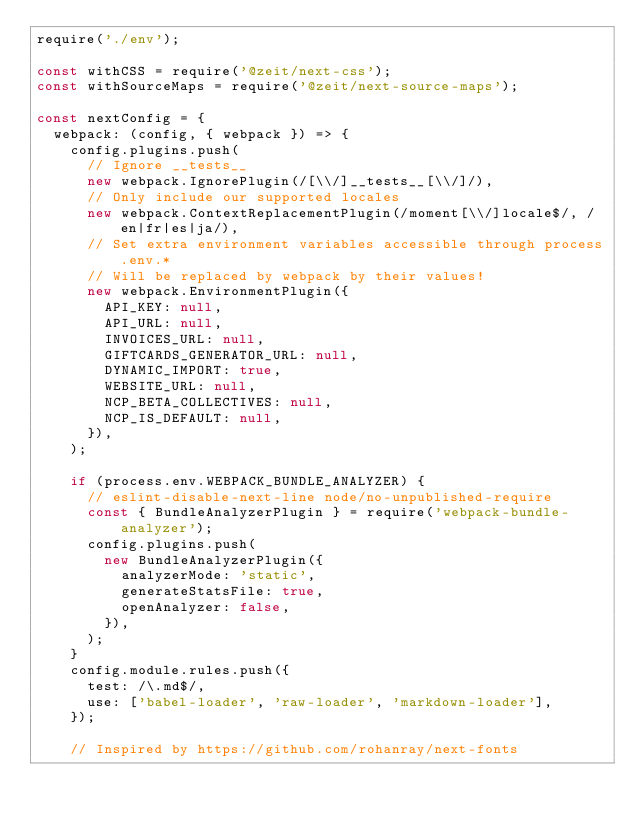<code> <loc_0><loc_0><loc_500><loc_500><_JavaScript_>require('./env');

const withCSS = require('@zeit/next-css');
const withSourceMaps = require('@zeit/next-source-maps');

const nextConfig = {
  webpack: (config, { webpack }) => {
    config.plugins.push(
      // Ignore __tests__
      new webpack.IgnorePlugin(/[\\/]__tests__[\\/]/),
      // Only include our supported locales
      new webpack.ContextReplacementPlugin(/moment[\\/]locale$/, /en|fr|es|ja/),
      // Set extra environment variables accessible through process.env.*
      // Will be replaced by webpack by their values!
      new webpack.EnvironmentPlugin({
        API_KEY: null,
        API_URL: null,
        INVOICES_URL: null,
        GIFTCARDS_GENERATOR_URL: null,
        DYNAMIC_IMPORT: true,
        WEBSITE_URL: null,
        NCP_BETA_COLLECTIVES: null,
        NCP_IS_DEFAULT: null,
      }),
    );

    if (process.env.WEBPACK_BUNDLE_ANALYZER) {
      // eslint-disable-next-line node/no-unpublished-require
      const { BundleAnalyzerPlugin } = require('webpack-bundle-analyzer');
      config.plugins.push(
        new BundleAnalyzerPlugin({
          analyzerMode: 'static',
          generateStatsFile: true,
          openAnalyzer: false,
        }),
      );
    }
    config.module.rules.push({
      test: /\.md$/,
      use: ['babel-loader', 'raw-loader', 'markdown-loader'],
    });

    // Inspired by https://github.com/rohanray/next-fonts</code> 